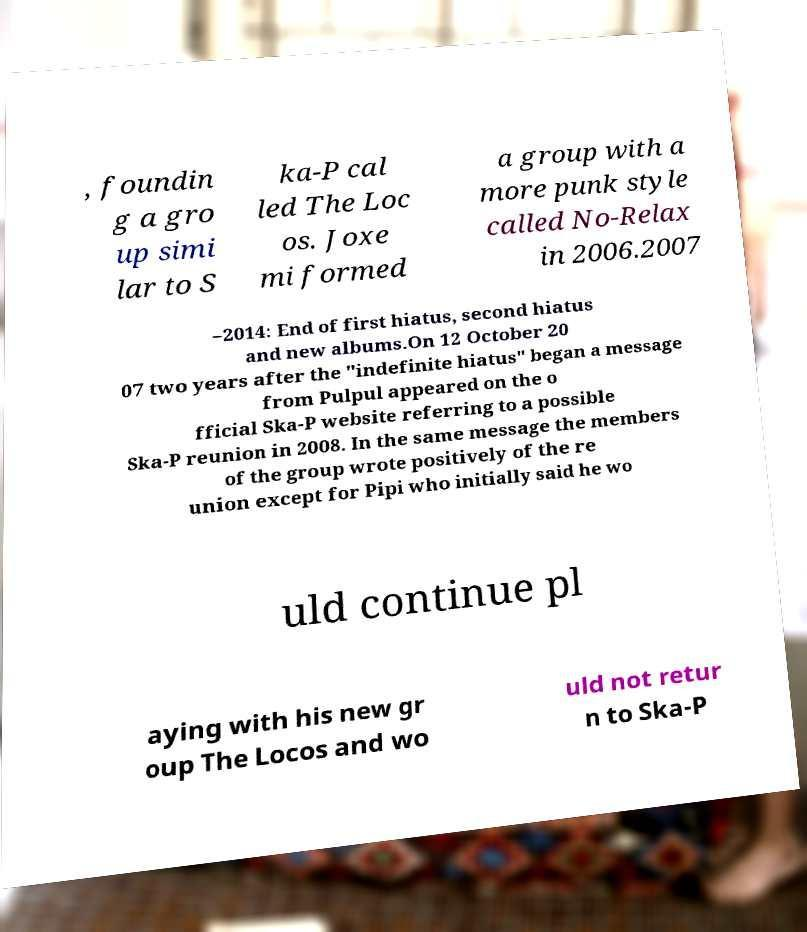For documentation purposes, I need the text within this image transcribed. Could you provide that? , foundin g a gro up simi lar to S ka-P cal led The Loc os. Joxe mi formed a group with a more punk style called No-Relax in 2006.2007 –2014: End of first hiatus, second hiatus and new albums.On 12 October 20 07 two years after the "indefinite hiatus" began a message from Pulpul appeared on the o fficial Ska-P website referring to a possible Ska-P reunion in 2008. In the same message the members of the group wrote positively of the re union except for Pipi who initially said he wo uld continue pl aying with his new gr oup The Locos and wo uld not retur n to Ska-P 